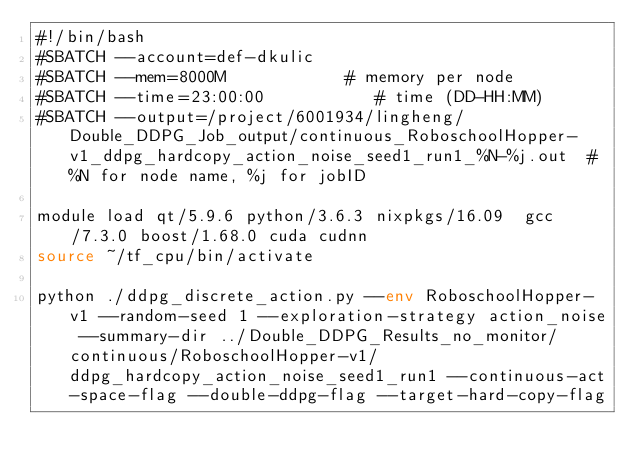Convert code to text. <code><loc_0><loc_0><loc_500><loc_500><_Bash_>#!/bin/bash
#SBATCH --account=def-dkulic
#SBATCH --mem=8000M            # memory per node
#SBATCH --time=23:00:00           # time (DD-HH:MM)
#SBATCH --output=/project/6001934/lingheng/Double_DDPG_Job_output/continuous_RoboschoolHopper-v1_ddpg_hardcopy_action_noise_seed1_run1_%N-%j.out  # %N for node name, %j for jobID

module load qt/5.9.6 python/3.6.3 nixpkgs/16.09  gcc/7.3.0 boost/1.68.0 cuda cudnn
source ~/tf_cpu/bin/activate

python ./ddpg_discrete_action.py --env RoboschoolHopper-v1 --random-seed 1 --exploration-strategy action_noise --summary-dir ../Double_DDPG_Results_no_monitor/continuous/RoboschoolHopper-v1/ddpg_hardcopy_action_noise_seed1_run1 --continuous-act-space-flag --double-ddpg-flag --target-hard-copy-flag 

</code> 